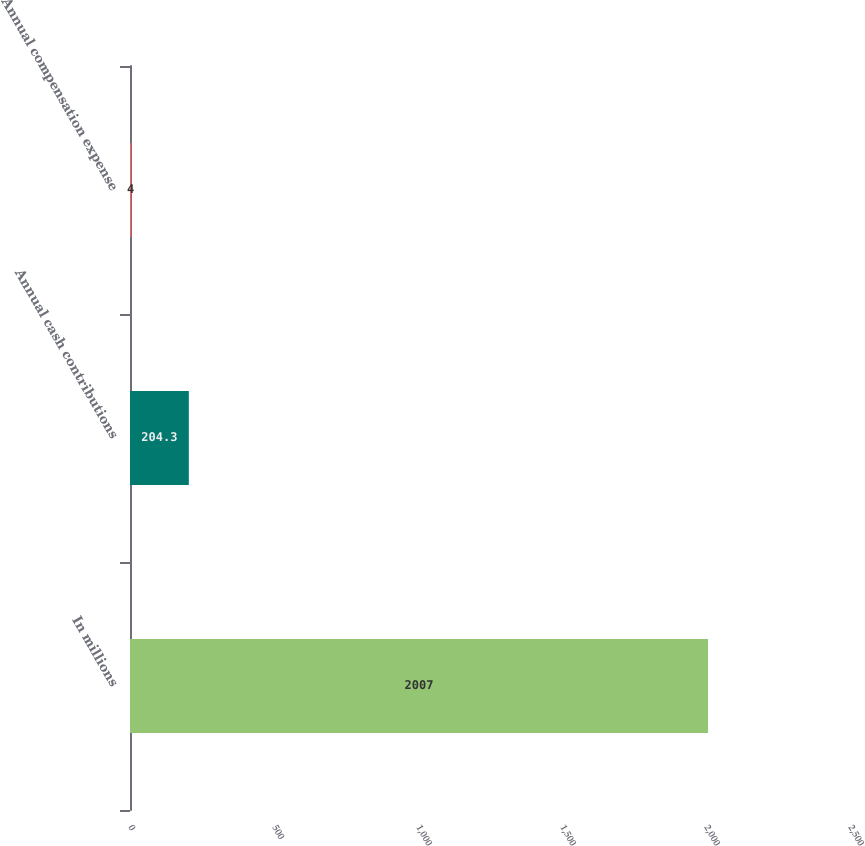<chart> <loc_0><loc_0><loc_500><loc_500><bar_chart><fcel>In millions<fcel>Annual cash contributions<fcel>Annual compensation expense<nl><fcel>2007<fcel>204.3<fcel>4<nl></chart> 